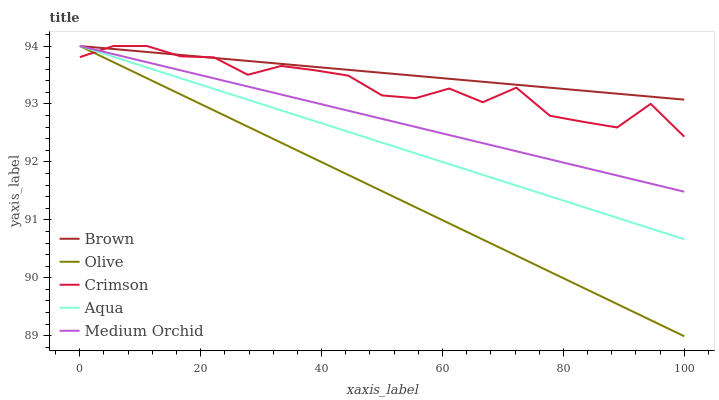Does Olive have the minimum area under the curve?
Answer yes or no. Yes. Does Brown have the maximum area under the curve?
Answer yes or no. Yes. Does Medium Orchid have the minimum area under the curve?
Answer yes or no. No. Does Medium Orchid have the maximum area under the curve?
Answer yes or no. No. Is Olive the smoothest?
Answer yes or no. Yes. Is Crimson the roughest?
Answer yes or no. Yes. Is Brown the smoothest?
Answer yes or no. No. Is Brown the roughest?
Answer yes or no. No. Does Medium Orchid have the lowest value?
Answer yes or no. No. 